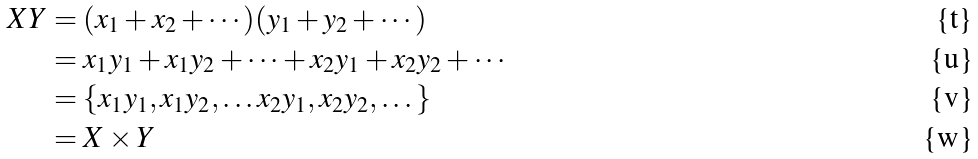Convert formula to latex. <formula><loc_0><loc_0><loc_500><loc_500>X Y & = ( x _ { 1 } + x _ { 2 } + \cdots ) ( y _ { 1 } + y _ { 2 } + \cdots ) \\ & = x _ { 1 } y _ { 1 } + x _ { 1 } y _ { 2 } + \cdots + x _ { 2 } y _ { 1 } + x _ { 2 } y _ { 2 } + \cdots \\ & = \{ x _ { 1 } y _ { 1 } , x _ { 1 } y _ { 2 } , \dots x _ { 2 } y _ { 1 } , x _ { 2 } y _ { 2 } , \dots \} \\ & = X \times Y</formula> 